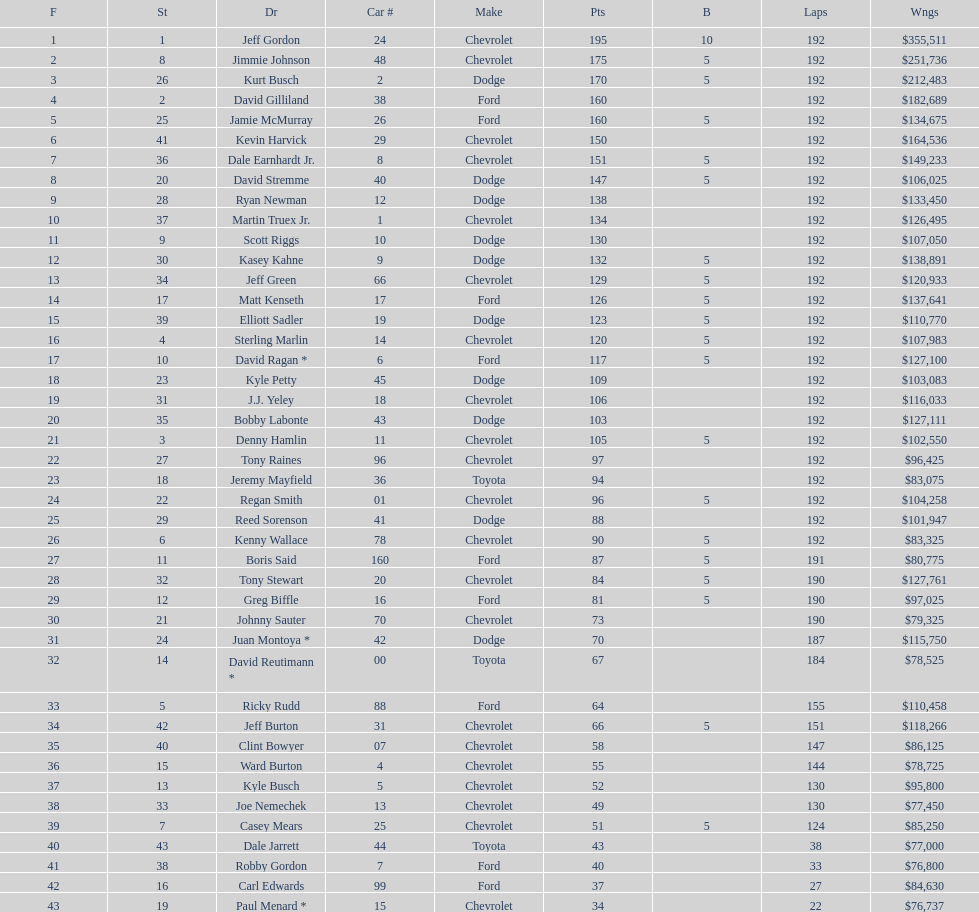Who is first in number of winnings on this list? Jeff Gordon. Would you mind parsing the complete table? {'header': ['F', 'St', 'Dr', 'Car #', 'Make', 'Pts', 'B', 'Laps', 'Wngs'], 'rows': [['1', '1', 'Jeff Gordon', '24', 'Chevrolet', '195', '10', '192', '$355,511'], ['2', '8', 'Jimmie Johnson', '48', 'Chevrolet', '175', '5', '192', '$251,736'], ['3', '26', 'Kurt Busch', '2', 'Dodge', '170', '5', '192', '$212,483'], ['4', '2', 'David Gilliland', '38', 'Ford', '160', '', '192', '$182,689'], ['5', '25', 'Jamie McMurray', '26', 'Ford', '160', '5', '192', '$134,675'], ['6', '41', 'Kevin Harvick', '29', 'Chevrolet', '150', '', '192', '$164,536'], ['7', '36', 'Dale Earnhardt Jr.', '8', 'Chevrolet', '151', '5', '192', '$149,233'], ['8', '20', 'David Stremme', '40', 'Dodge', '147', '5', '192', '$106,025'], ['9', '28', 'Ryan Newman', '12', 'Dodge', '138', '', '192', '$133,450'], ['10', '37', 'Martin Truex Jr.', '1', 'Chevrolet', '134', '', '192', '$126,495'], ['11', '9', 'Scott Riggs', '10', 'Dodge', '130', '', '192', '$107,050'], ['12', '30', 'Kasey Kahne', '9', 'Dodge', '132', '5', '192', '$138,891'], ['13', '34', 'Jeff Green', '66', 'Chevrolet', '129', '5', '192', '$120,933'], ['14', '17', 'Matt Kenseth', '17', 'Ford', '126', '5', '192', '$137,641'], ['15', '39', 'Elliott Sadler', '19', 'Dodge', '123', '5', '192', '$110,770'], ['16', '4', 'Sterling Marlin', '14', 'Chevrolet', '120', '5', '192', '$107,983'], ['17', '10', 'David Ragan *', '6', 'Ford', '117', '5', '192', '$127,100'], ['18', '23', 'Kyle Petty', '45', 'Dodge', '109', '', '192', '$103,083'], ['19', '31', 'J.J. Yeley', '18', 'Chevrolet', '106', '', '192', '$116,033'], ['20', '35', 'Bobby Labonte', '43', 'Dodge', '103', '', '192', '$127,111'], ['21', '3', 'Denny Hamlin', '11', 'Chevrolet', '105', '5', '192', '$102,550'], ['22', '27', 'Tony Raines', '96', 'Chevrolet', '97', '', '192', '$96,425'], ['23', '18', 'Jeremy Mayfield', '36', 'Toyota', '94', '', '192', '$83,075'], ['24', '22', 'Regan Smith', '01', 'Chevrolet', '96', '5', '192', '$104,258'], ['25', '29', 'Reed Sorenson', '41', 'Dodge', '88', '', '192', '$101,947'], ['26', '6', 'Kenny Wallace', '78', 'Chevrolet', '90', '5', '192', '$83,325'], ['27', '11', 'Boris Said', '160', 'Ford', '87', '5', '191', '$80,775'], ['28', '32', 'Tony Stewart', '20', 'Chevrolet', '84', '5', '190', '$127,761'], ['29', '12', 'Greg Biffle', '16', 'Ford', '81', '5', '190', '$97,025'], ['30', '21', 'Johnny Sauter', '70', 'Chevrolet', '73', '', '190', '$79,325'], ['31', '24', 'Juan Montoya *', '42', 'Dodge', '70', '', '187', '$115,750'], ['32', '14', 'David Reutimann *', '00', 'Toyota', '67', '', '184', '$78,525'], ['33', '5', 'Ricky Rudd', '88', 'Ford', '64', '', '155', '$110,458'], ['34', '42', 'Jeff Burton', '31', 'Chevrolet', '66', '5', '151', '$118,266'], ['35', '40', 'Clint Bowyer', '07', 'Chevrolet', '58', '', '147', '$86,125'], ['36', '15', 'Ward Burton', '4', 'Chevrolet', '55', '', '144', '$78,725'], ['37', '13', 'Kyle Busch', '5', 'Chevrolet', '52', '', '130', '$95,800'], ['38', '33', 'Joe Nemechek', '13', 'Chevrolet', '49', '', '130', '$77,450'], ['39', '7', 'Casey Mears', '25', 'Chevrolet', '51', '5', '124', '$85,250'], ['40', '43', 'Dale Jarrett', '44', 'Toyota', '43', '', '38', '$77,000'], ['41', '38', 'Robby Gordon', '7', 'Ford', '40', '', '33', '$76,800'], ['42', '16', 'Carl Edwards', '99', 'Ford', '37', '', '27', '$84,630'], ['43', '19', 'Paul Menard *', '15', 'Chevrolet', '34', '', '22', '$76,737']]} 